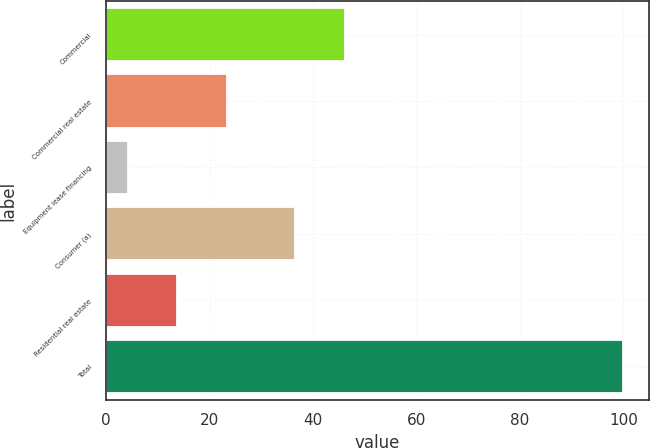Convert chart. <chart><loc_0><loc_0><loc_500><loc_500><bar_chart><fcel>Commercial<fcel>Commercial real estate<fcel>Equipment lease financing<fcel>Consumer (a)<fcel>Residential real estate<fcel>Total<nl><fcel>46.18<fcel>23.36<fcel>4.2<fcel>36.6<fcel>13.78<fcel>100<nl></chart> 